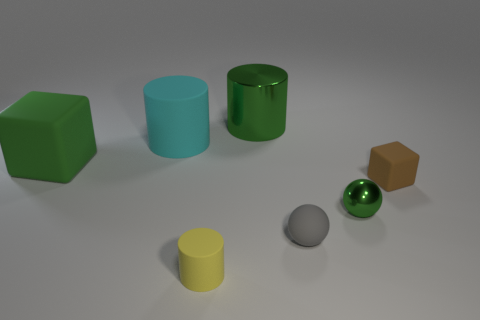Subtract all tiny matte cylinders. How many cylinders are left? 2 Subtract all yellow cylinders. How many cylinders are left? 2 Subtract 2 blocks. How many blocks are left? 0 Subtract all cylinders. How many objects are left? 4 Add 1 gray rubber objects. How many objects exist? 8 Add 2 yellow matte spheres. How many yellow matte spheres exist? 2 Subtract 0 blue cylinders. How many objects are left? 7 Subtract all red blocks. Subtract all purple balls. How many blocks are left? 2 Subtract all purple balls. How many yellow blocks are left? 0 Subtract all cyan matte things. Subtract all tiny yellow cylinders. How many objects are left? 5 